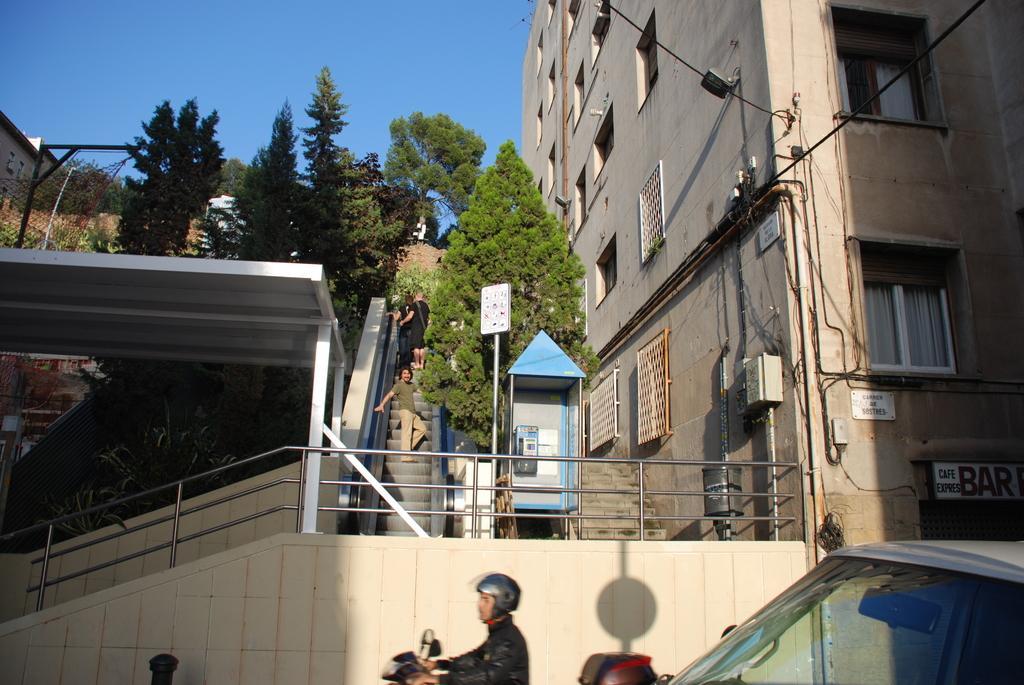Could you give a brief overview of what you see in this image? In the picture we can see a part of a car windshield and beside it, we can see a man riding a bike and beside him we can see a wall on it, we can see a railing and shed and we can see steps with some people standing on it and beside it we can see some tree and building with windows to it and behind the shed we can see some trees and sky. 